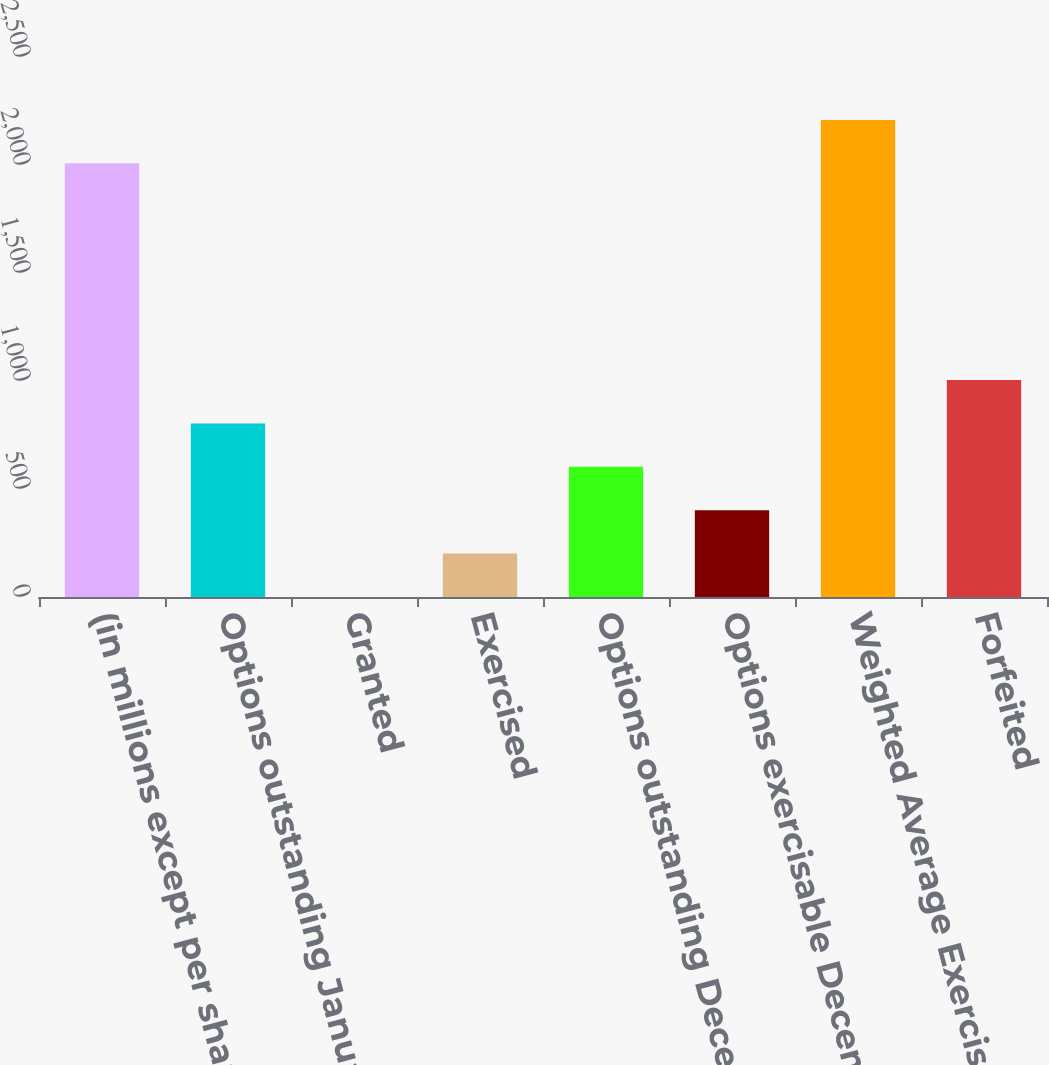<chart> <loc_0><loc_0><loc_500><loc_500><bar_chart><fcel>(in millions except per share<fcel>Options outstanding January 1<fcel>Granted<fcel>Exercised<fcel>Options outstanding December<fcel>Options exercisable December<fcel>Weighted Average Exercise<fcel>Forfeited<nl><fcel>2008<fcel>803.5<fcel>0.5<fcel>201.25<fcel>602.75<fcel>402<fcel>2208.75<fcel>1004.25<nl></chart> 